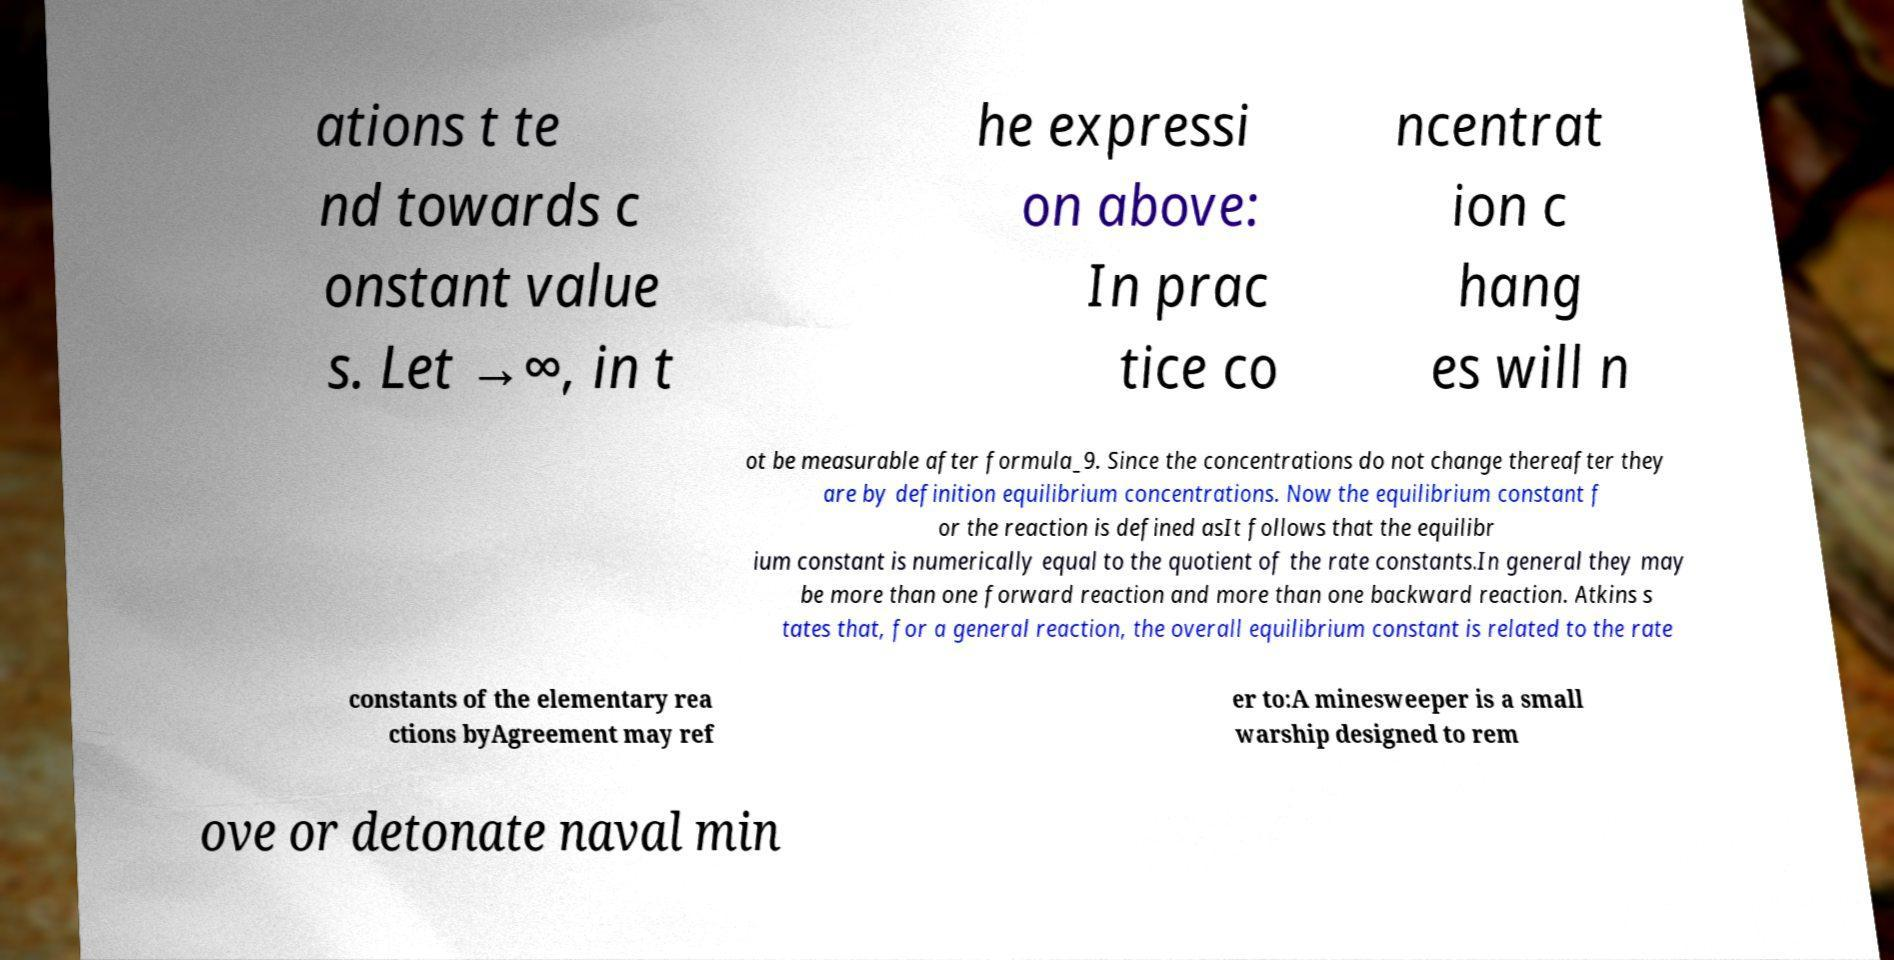For documentation purposes, I need the text within this image transcribed. Could you provide that? ations t te nd towards c onstant value s. Let →∞, in t he expressi on above: In prac tice co ncentrat ion c hang es will n ot be measurable after formula_9. Since the concentrations do not change thereafter they are by definition equilibrium concentrations. Now the equilibrium constant f or the reaction is defined asIt follows that the equilibr ium constant is numerically equal to the quotient of the rate constants.In general they may be more than one forward reaction and more than one backward reaction. Atkins s tates that, for a general reaction, the overall equilibrium constant is related to the rate constants of the elementary rea ctions byAgreement may ref er to:A minesweeper is a small warship designed to rem ove or detonate naval min 